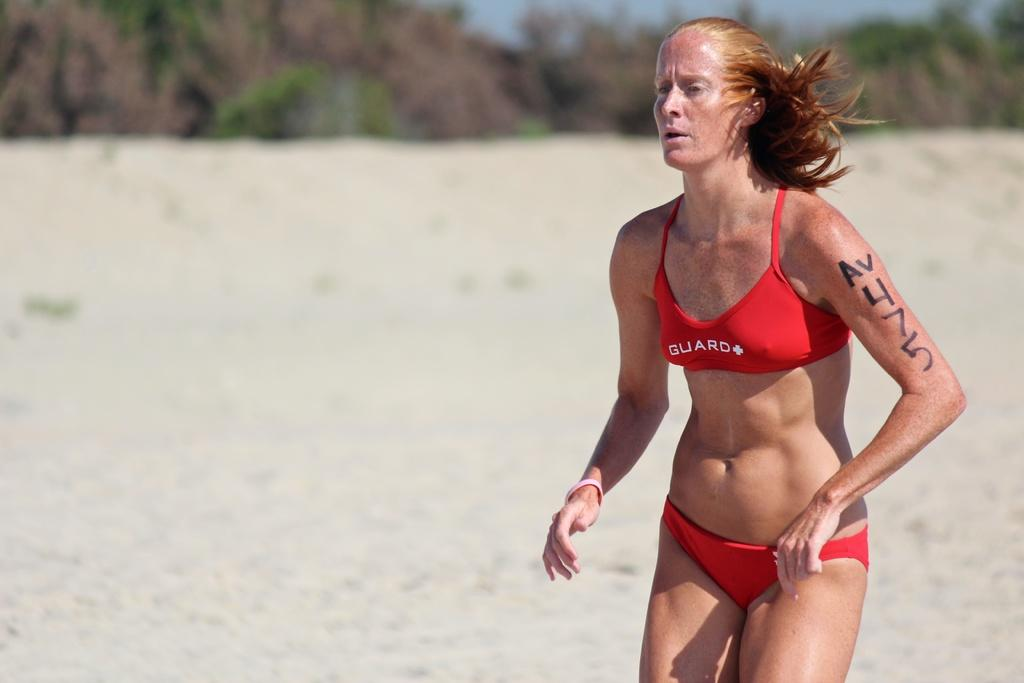<image>
Give a short and clear explanation of the subsequent image. A woman in a bikini with the numbers 7 and 5 on her arm. 